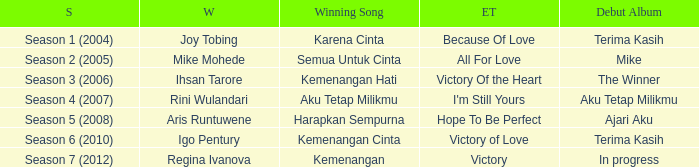Which English winning song had the winner aris runtuwene? Hope To Be Perfect. 